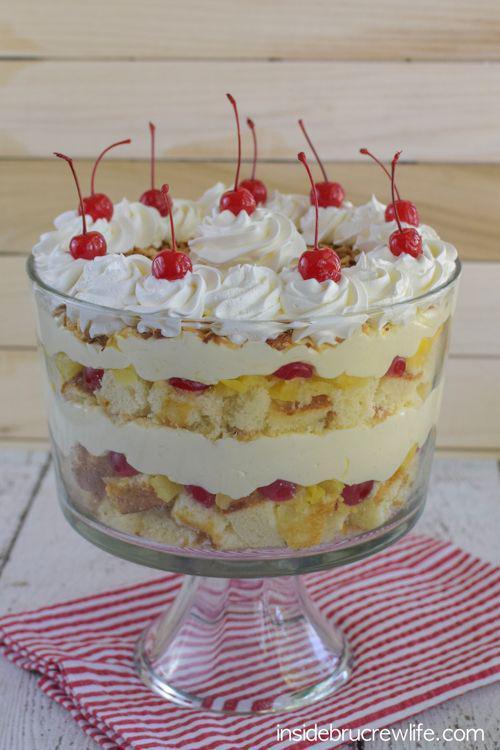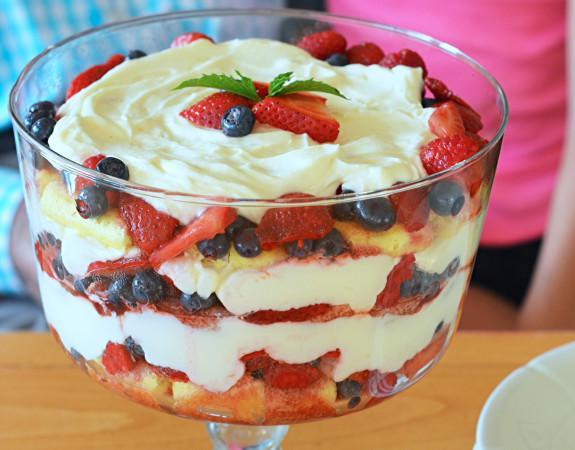The first image is the image on the left, the second image is the image on the right. For the images shown, is this caption "The dessert is sitting on a folded red and white cloth in one image." true? Answer yes or no. Yes. The first image is the image on the left, the second image is the image on the right. For the images shown, is this caption "Two large fancy layered desserts are made with sliced strawberries." true? Answer yes or no. No. 